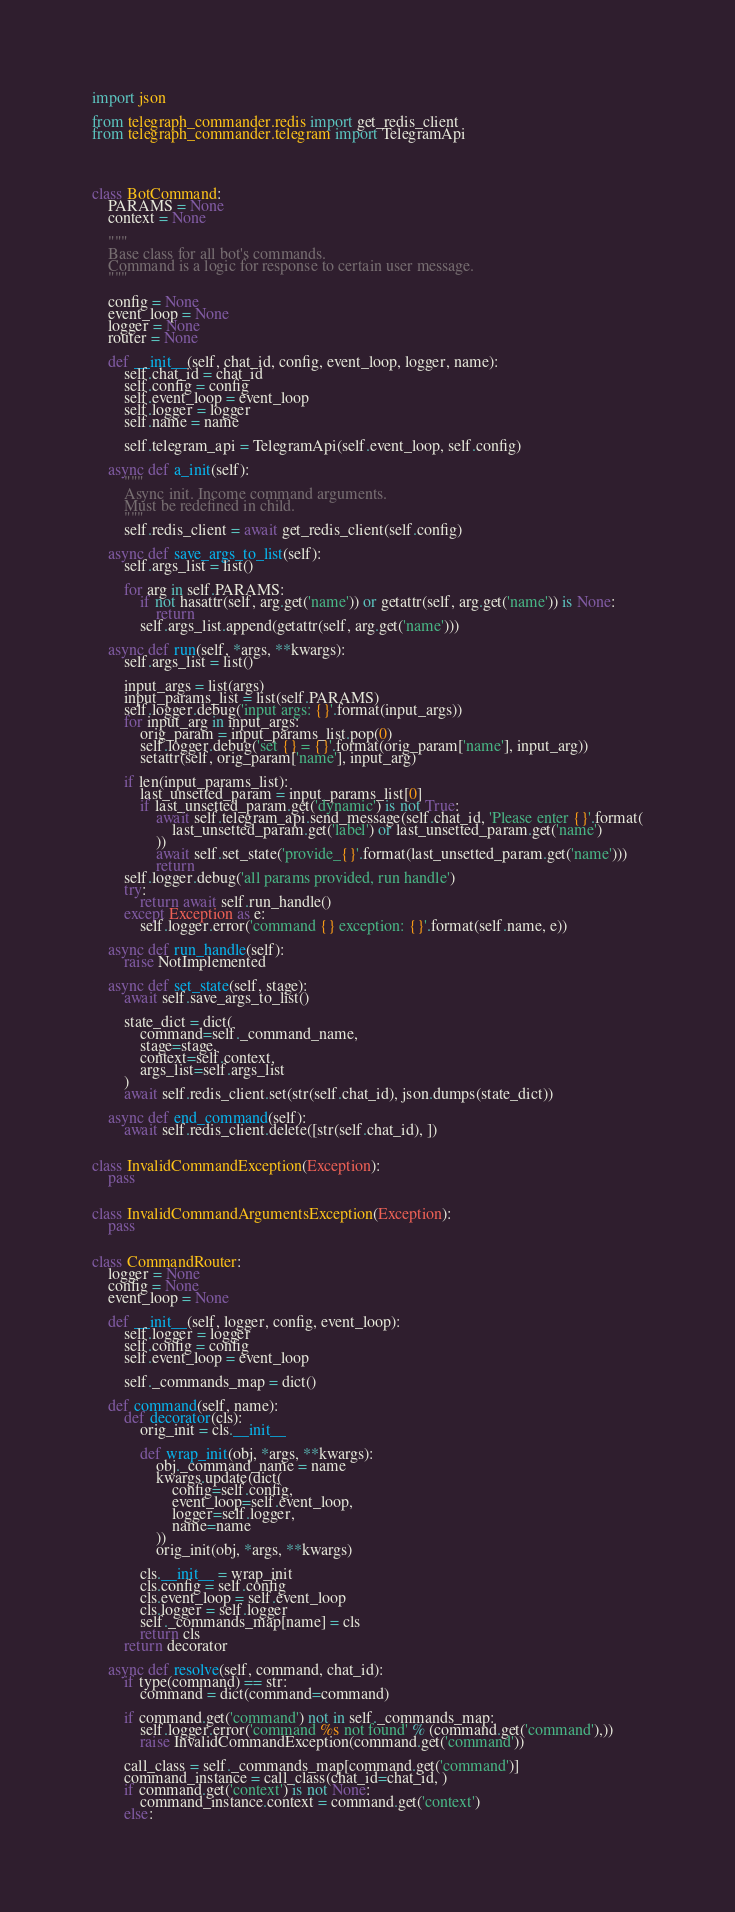Convert code to text. <code><loc_0><loc_0><loc_500><loc_500><_Python_>import json

from telegraph_commander.redis import get_redis_client
from telegraph_commander.telegram import TelegramApi




class BotCommand:
    PARAMS = None
    context = None

    """
    Base class for all bot's commands.
    Command is a logic for response to certain user message.
    """

    config = None
    event_loop = None
    logger = None
    router = None

    def __init__(self, chat_id, config, event_loop, logger, name):
        self.chat_id = chat_id
        self.config = config
        self.event_loop = event_loop
        self.logger = logger
        self.name = name

        self.telegram_api = TelegramApi(self.event_loop, self.config)

    async def a_init(self):
        """
        Async init. Income command arguments.
        Must be redefined in child.
        """
        self.redis_client = await get_redis_client(self.config)

    async def save_args_to_list(self):
        self.args_list = list()

        for arg in self.PARAMS:
            if not hasattr(self, arg.get('name')) or getattr(self, arg.get('name')) is None:
                return
            self.args_list.append(getattr(self, arg.get('name')))

    async def run(self, *args, **kwargs):
        self.args_list = list()

        input_args = list(args)
        input_params_list = list(self.PARAMS)
        self.logger.debug('input args: {}'.format(input_args))
        for input_arg in input_args:
            orig_param = input_params_list.pop(0)
            self.logger.debug('set {} = {}'.format(orig_param['name'], input_arg))
            setattr(self, orig_param['name'], input_arg)

        if len(input_params_list):
            last_unsetted_param = input_params_list[0]
            if last_unsetted_param.get('dynamic') is not True:
                await self.telegram_api.send_message(self.chat_id, 'Please enter {}'.format(
                    last_unsetted_param.get('label') or last_unsetted_param.get('name')
                ))
                await self.set_state('provide_{}'.format(last_unsetted_param.get('name')))
                return
        self.logger.debug('all params provided, run handle')
        try:
            return await self.run_handle()
        except Exception as e:
            self.logger.error('command {} exception: {}'.format(self.name, e))

    async def run_handle(self):
        raise NotImplemented

    async def set_state(self, stage):
        await self.save_args_to_list()

        state_dict = dict(
            command=self._command_name,
            stage=stage,
            context=self.context,
            args_list=self.args_list
        )
        await self.redis_client.set(str(self.chat_id), json.dumps(state_dict))

    async def end_command(self):
        await self.redis_client.delete([str(self.chat_id), ])


class InvalidCommandException(Exception):
    pass


class InvalidCommandArgumentsException(Exception):
    pass


class CommandRouter:
    logger = None
    config = None
    event_loop = None

    def __init__(self, logger, config, event_loop):
        self.logger = logger
        self.config = config
        self.event_loop = event_loop

        self._commands_map = dict()

    def command(self, name):
        def decorator(cls):
            orig_init = cls.__init__

            def wrap_init(obj, *args, **kwargs):
                obj._command_name = name
                kwargs.update(dict(
                    config=self.config,
                    event_loop=self.event_loop,
                    logger=self.logger,
                    name=name
                ))
                orig_init(obj, *args, **kwargs)

            cls.__init__ = wrap_init
            cls.config = self.config
            cls.event_loop = self.event_loop
            cls.logger = self.logger
            self._commands_map[name] = cls
            return cls
        return decorator

    async def resolve(self, command, chat_id):
        if type(command) == str:
            command = dict(command=command)

        if command.get('command') not in self._commands_map:
            self.logger.error('command %s not found' % (command.get('command'),))
            raise InvalidCommandException(command.get('command'))

        call_class = self._commands_map[command.get('command')]
        command_instance = call_class(chat_id=chat_id, )
        if command.get('context') is not None:
            command_instance.context = command.get('context')
        else:</code> 